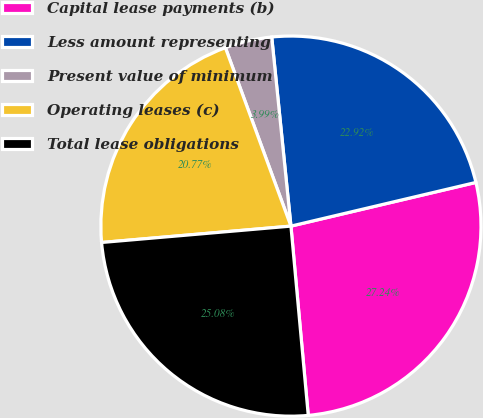<chart> <loc_0><loc_0><loc_500><loc_500><pie_chart><fcel>Capital lease payments (b)<fcel>Less amount representing<fcel>Present value of minimum<fcel>Operating leases (c)<fcel>Total lease obligations<nl><fcel>27.24%<fcel>22.92%<fcel>3.99%<fcel>20.77%<fcel>25.08%<nl></chart> 